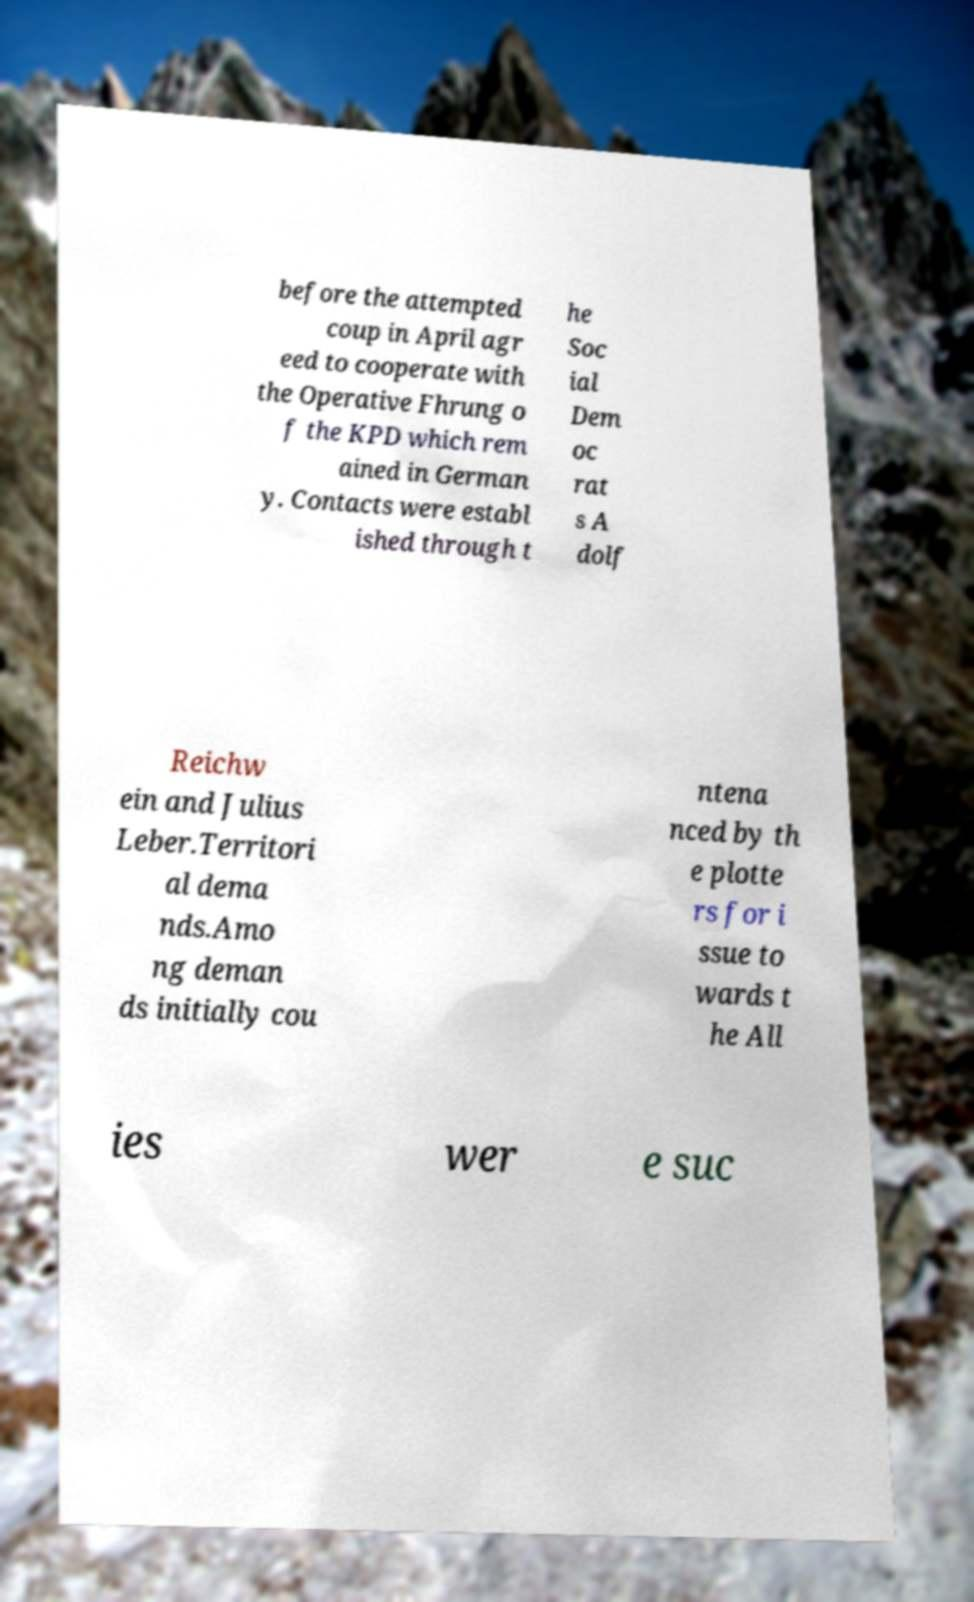Could you assist in decoding the text presented in this image and type it out clearly? before the attempted coup in April agr eed to cooperate with the Operative Fhrung o f the KPD which rem ained in German y. Contacts were establ ished through t he Soc ial Dem oc rat s A dolf Reichw ein and Julius Leber.Territori al dema nds.Amo ng deman ds initially cou ntena nced by th e plotte rs for i ssue to wards t he All ies wer e suc 